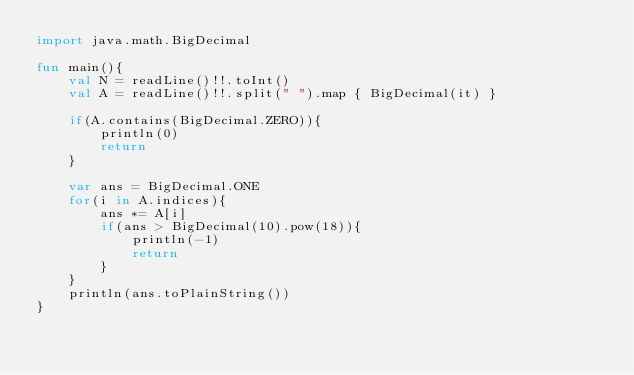<code> <loc_0><loc_0><loc_500><loc_500><_Kotlin_>import java.math.BigDecimal

fun main(){
    val N = readLine()!!.toInt()
    val A = readLine()!!.split(" ").map { BigDecimal(it) }

    if(A.contains(BigDecimal.ZERO)){
        println(0)
        return
    }

    var ans = BigDecimal.ONE
    for(i in A.indices){
        ans *= A[i]
        if(ans > BigDecimal(10).pow(18)){
            println(-1)
            return
        }
    }
    println(ans.toPlainString())
}</code> 